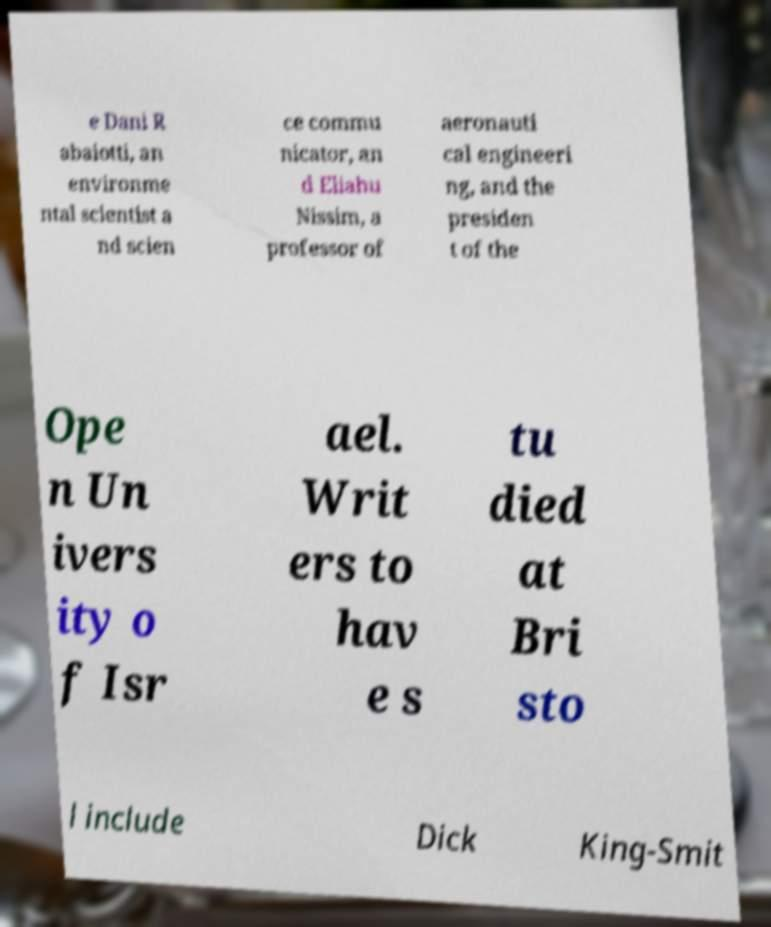There's text embedded in this image that I need extracted. Can you transcribe it verbatim? e Dani R abaiotti, an environme ntal scientist a nd scien ce commu nicator, an d Eliahu Nissim, a professor of aeronauti cal engineeri ng, and the presiden t of the Ope n Un ivers ity o f Isr ael. Writ ers to hav e s tu died at Bri sto l include Dick King-Smit 